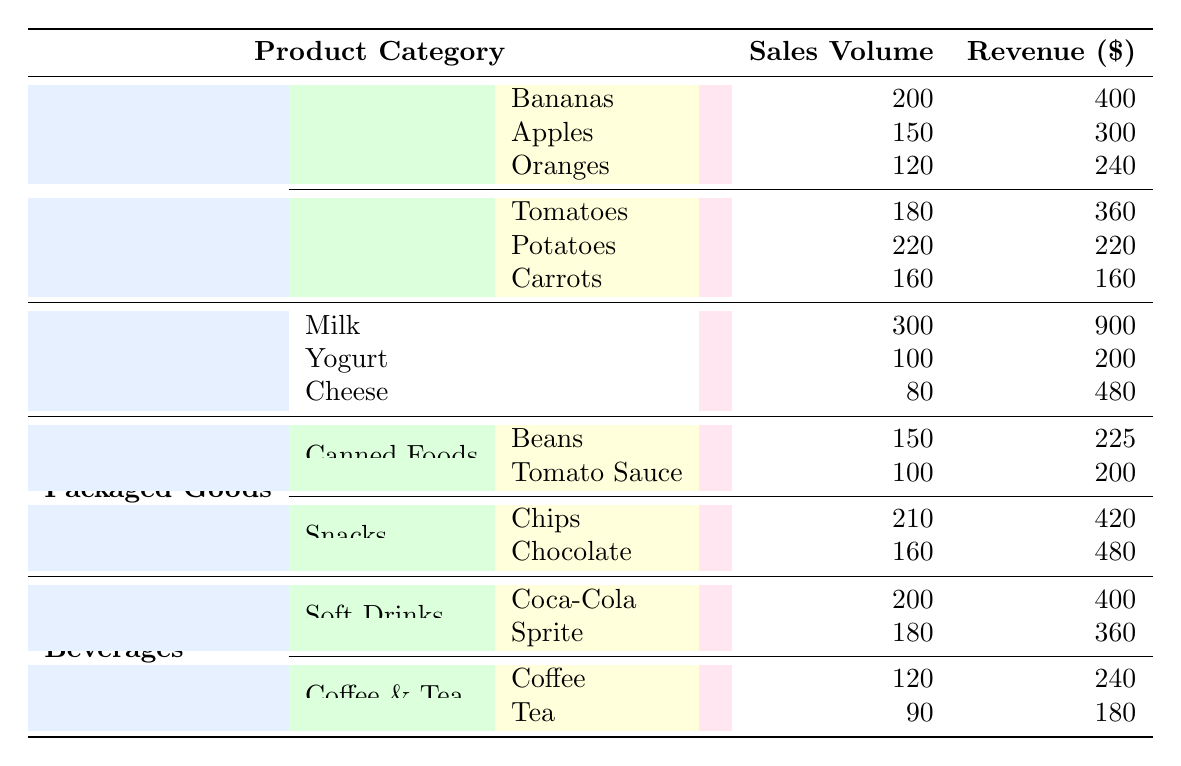What is the total sales volume of Fresh Produce? The sales volume of Fresh Produce consists of the sales of Fruits and Vegetables. Adding them up: (200 + 150 + 120) for Fruits and (180 + 220 + 160) for Vegetables gives us: 200 + 150 + 120 + 180 + 220 + 160 = 1030.
Answer: 1030 Which dairy product generated the highest revenue? We look at the revenue figures for each dairy product: Milk is 900, Yogurt is 200, and Cheese is 480. The highest revenue is from Milk, which has a revenue of 900.
Answer: Milk How many different types of snacks are listed in the table? The types of snacks listed include Chips and Chocolate. There are two distinct entries under the Snacks category.
Answer: 2 What is the average revenue for Canned Foods? Canned Foods include Beans and Tomato Sauce. The revenue for Beans is 225 and for Tomato Sauce it is 200. The average is calculated as (225 + 200) / 2 = 212.5.
Answer: 212.5 Is the sales volume of Tomatoes greater than the sales volume of Bananas? The sales volume of Tomatoes is 180, while the sales volume of Bananas is 200. Since 180 is less than 200, the statement is false.
Answer: No What is the total revenue from all Beverages? To find the total revenue from Beverages, we add revenue from Soft Drinks (Coca-Cola and Sprite) which is (400 + 360) and from Coffee & Tea (Coffee and Tea) which is (240 + 180). Total revenue = (400 + 360) + (240 + 180) = 1180.
Answer: 1180 Are there more fruits or vegetables listed in the table? There are 3 types of fruits (Bananas, Apples, Oranges) and 3 types of vegetables (Tomatoes, Potatoes, Carrots). Since both have the same count, the answer is neither has more.
Answer: No What is the total sales volume for all Dairy Products combined? The sales volume for Dairy Products includes Milk (300), Yogurt (100), and Cheese (80). Adding these gives us a total sales volume of 300 + 100 + 80 = 480.
Answer: 480 Which product category has the highest combined revenue? We calculate the total revenue for each category: Fresh Produce (400 + 300 + 240 + 360 + 220 + 160 = 1680), Dairy Products (900 + 200 + 480 = 1580), Packaged Goods (225 + 200 + 420 + 480 = 1325), and Beverages (400 + 360 + 240 + 180 = 1180). Fresh Produce has the highest total revenue of 1680.
Answer: Fresh Produce 